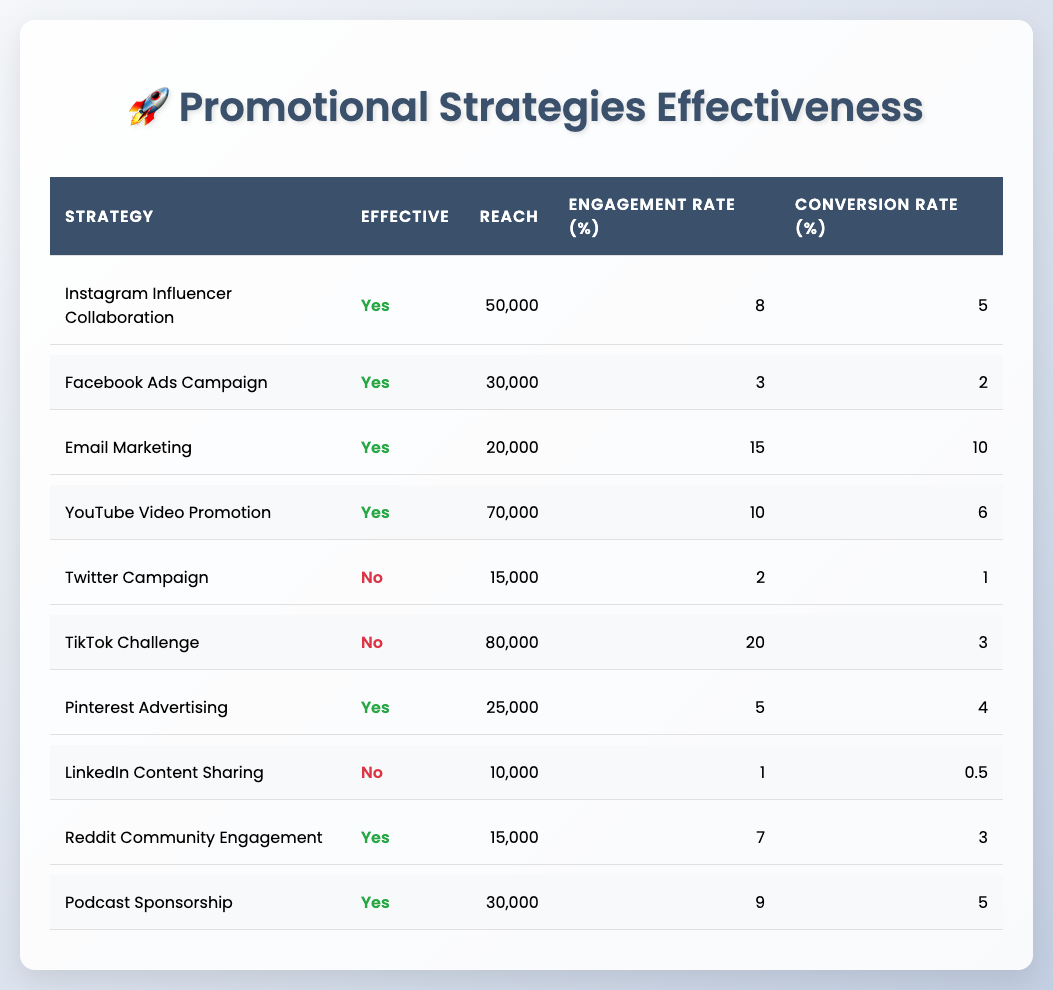What is the reach of the YouTube Video Promotion strategy? From the table, I can find the row for YouTube Video Promotion. The corresponding reach listed is 70,000.
Answer: 70,000 How many promotional strategies are effective? By analyzing the table, I can count the strategies labeled as "Yes" in the Effective column. There are 6 effective strategies.
Answer: 6 What is the average engagement rate of the effective strategies? To find the average engagement rate, I take the engagement rates of the effective strategies (8, 3, 15, 10, 5, 7, 9) and calculate the sum: 8 + 3 + 15 + 10 + 5 + 7 + 9 = 57. There are 6 effective strategies, so the average is 57/6 = 9.5.
Answer: 9.5 Are TikTok Challenge and Twitter Campaign both effective strategies? By checking the Effective column for both strategies, I see that TikTok Challenge is labeled "No" and Twitter Campaign is also labeled "No." Thus, both are ineffective.
Answer: No What is the difference in conversion rates between the highest and lowest effective strategies? First, identify the conversion rates for effective strategies: Instagram Influencer Collaboration (5), Email Marketing (10), YouTube Video Promotion (6), Pinterest Advertising (4), Reddit Community Engagement (3), Podcast Sponsorship (5). The highest conversion rate is 10 (Email Marketing) and the lowest is 3 (Reddit Community Engagement). The difference is 10 - 3 = 7.
Answer: 7 How does the reach of Email Marketing compare to that of Twitter Campaign? The reach for Email Marketing is 20,000, and the reach for Twitter Campaign is 15,000, thus Email Marketing has a greater reach than Twitter Campaign by 20,000 - 15,000 = 5,000.
Answer: 5,000 Which promotional strategy has the highest engagement rate and what is that rate? By reviewing the Engagement Rate column, the highest rate among the strategies is for Email Marketing, which has an engagement rate of 15.
Answer: 15 Is Pinterest Advertising more effective than the TikTok Challenge? Looking at both strategies in the Effective column, I see that Pinterest Advertising is "Yes" and TikTok Challenge is "No." Thus, Pinterest Advertising is indeed more effective.
Answer: Yes 